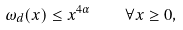<formula> <loc_0><loc_0><loc_500><loc_500>\omega _ { d } ( x ) \leq x ^ { 4 \alpha } \quad \forall x \geq 0 ,</formula> 